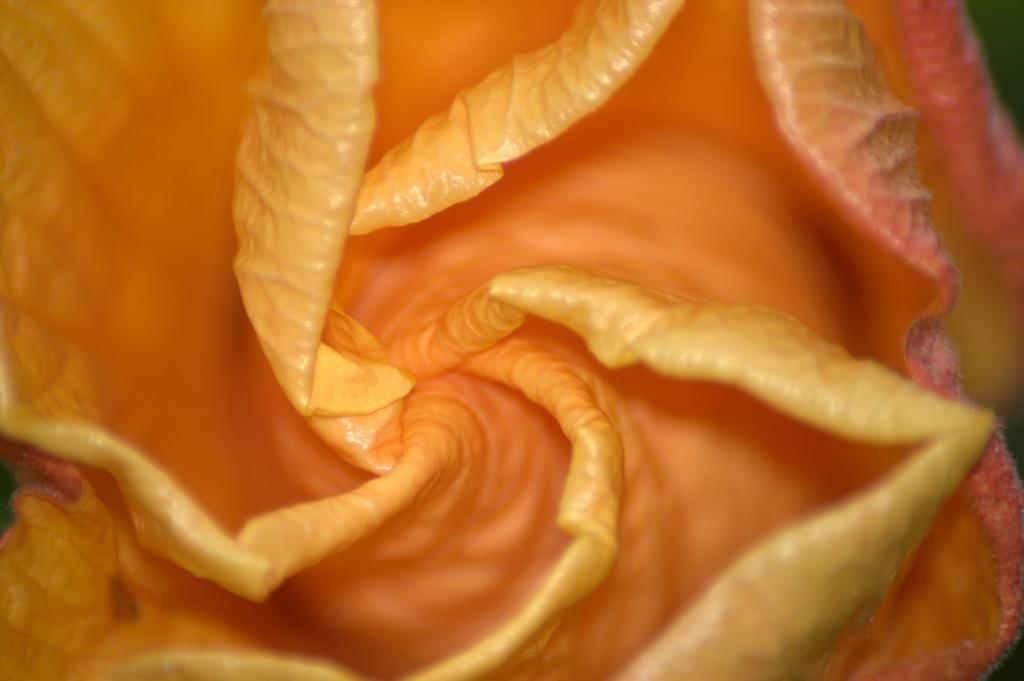What is the main subject of the image? There is a close-up view of a flower in the image. Can you describe the flower in the image? Unfortunately, the close-up view does not allow for a detailed description of the flower. What colors can be seen in the image? The colors of the flower are not clearly visible due to the close-up view. What type of crime is being committed in the image? There is no crime present in the image; it features a close-up view of a flower. How many balls are visible in the image? There are no balls present in the image; it features a close-up view of a flower. 